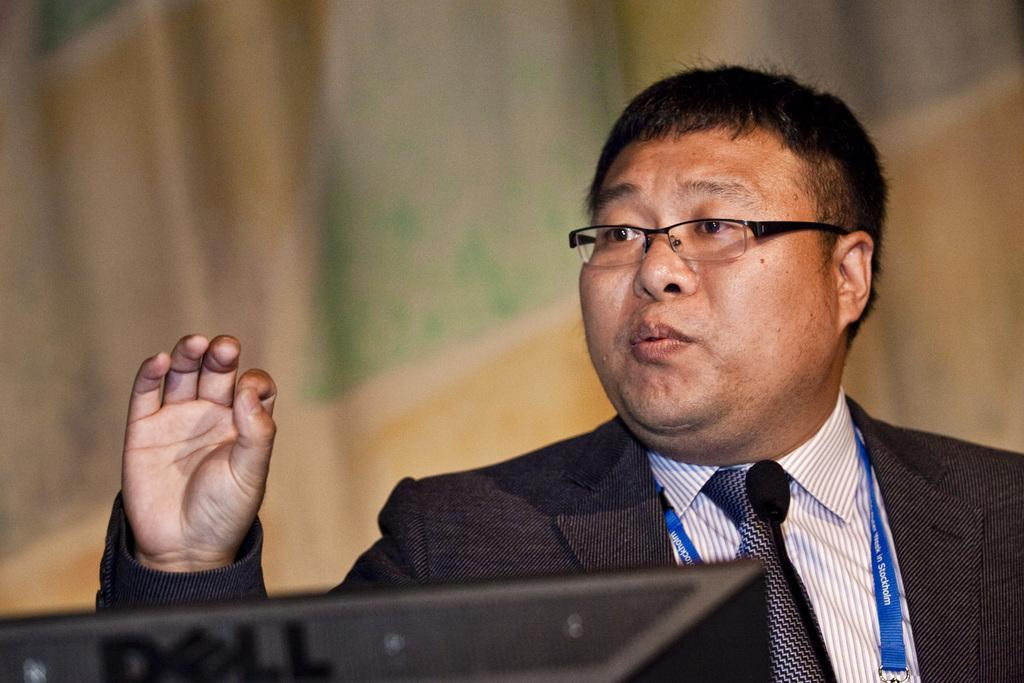Who is present in the image? There is a man in the image. What can be seen at the bottom of the image? There is an object at the bottom of the image. Can you describe the background of the image? The background of the image is blurred, but there is an object visible in it. What type of silk is being used for pleasure in the image? There is no silk or pleasure-related activity present in the image. 